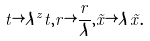Convert formula to latex. <formula><loc_0><loc_0><loc_500><loc_500>t \rightarrow \lambda ^ { z } t , r \rightarrow \frac { r } { \lambda } , \vec { x } \rightarrow \lambda \vec { x } .</formula> 